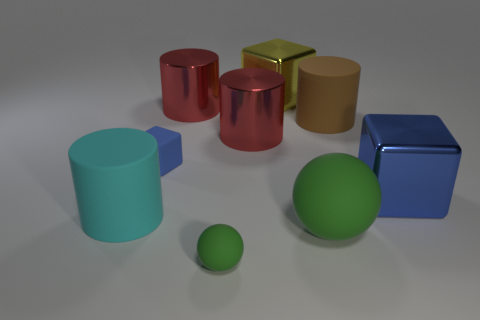Which objects in the image appear to be in contact with one another? Within the scene, the objects are positioned separately; however, two pairs of objects almost touch but maintain a slight distance between them. These are the bigger green sphere and the gold cube, as well as the smaller green sphere and the larger tan cylinder. The rest are clearly spaced apart, with no points of contact. 